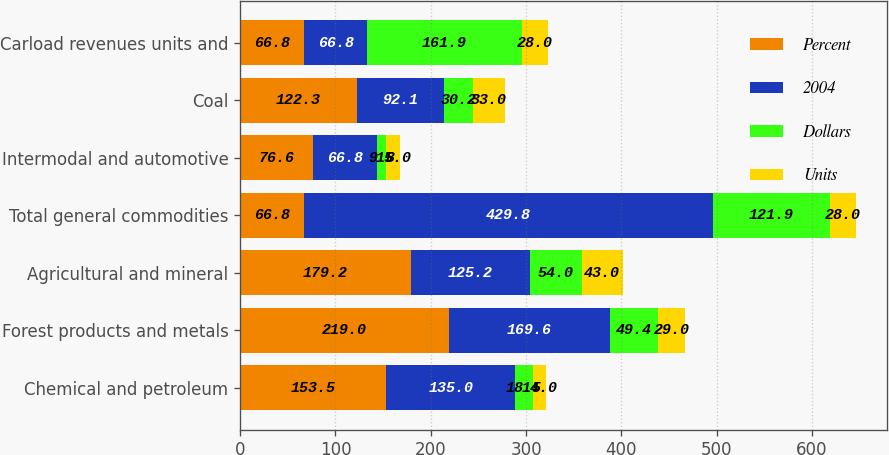<chart> <loc_0><loc_0><loc_500><loc_500><stacked_bar_chart><ecel><fcel>Chemical and petroleum<fcel>Forest products and metals<fcel>Agricultural and mineral<fcel>Total general commodities<fcel>Intermodal and automotive<fcel>Coal<fcel>Carload revenues units and<nl><fcel>Percent<fcel>153.5<fcel>219<fcel>179.2<fcel>66.8<fcel>76.6<fcel>122.3<fcel>66.8<nl><fcel>2004<fcel>135<fcel>169.6<fcel>125.2<fcel>429.8<fcel>66.8<fcel>92.1<fcel>66.8<nl><fcel>Dollars<fcel>18.5<fcel>49.4<fcel>54<fcel>121.9<fcel>9.8<fcel>30.2<fcel>161.9<nl><fcel>Units<fcel>14<fcel>29<fcel>43<fcel>28<fcel>15<fcel>33<fcel>28<nl></chart> 